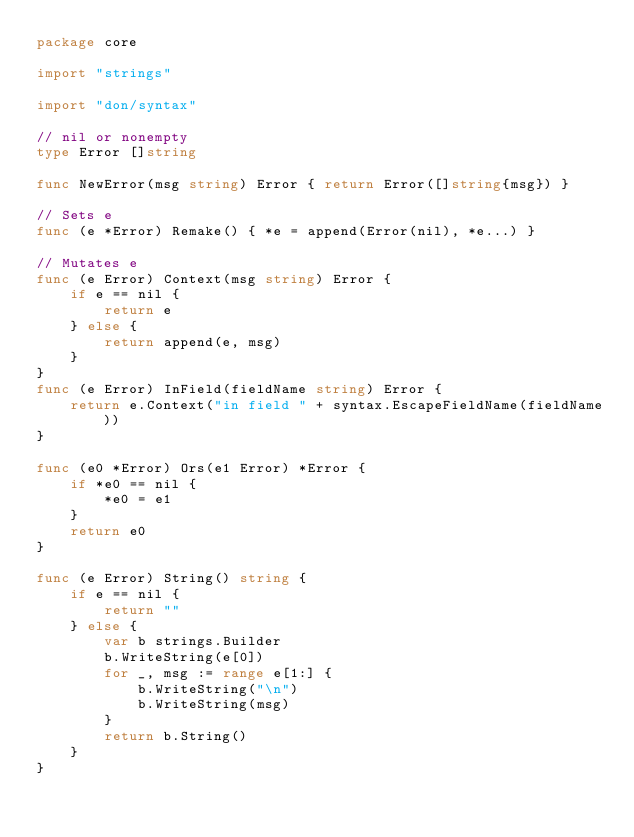<code> <loc_0><loc_0><loc_500><loc_500><_Go_>package core

import "strings"

import "don/syntax"

// nil or nonempty
type Error []string

func NewError(msg string) Error { return Error([]string{msg}) }

// Sets e
func (e *Error) Remake() { *e = append(Error(nil), *e...) }

// Mutates e
func (e Error) Context(msg string) Error {
	if e == nil {
		return e
	} else {
		return append(e, msg)
	}
}
func (e Error) InField(fieldName string) Error {
	return e.Context("in field " + syntax.EscapeFieldName(fieldName))
}

func (e0 *Error) Ors(e1 Error) *Error {
	if *e0 == nil {
		*e0 = e1
	}
	return e0
}

func (e Error) String() string {
	if e == nil {
		return ""
	} else {
		var b strings.Builder
		b.WriteString(e[0])
		for _, msg := range e[1:] {
			b.WriteString("\n")
			b.WriteString(msg)
		}
		return b.String()
	}
}
</code> 